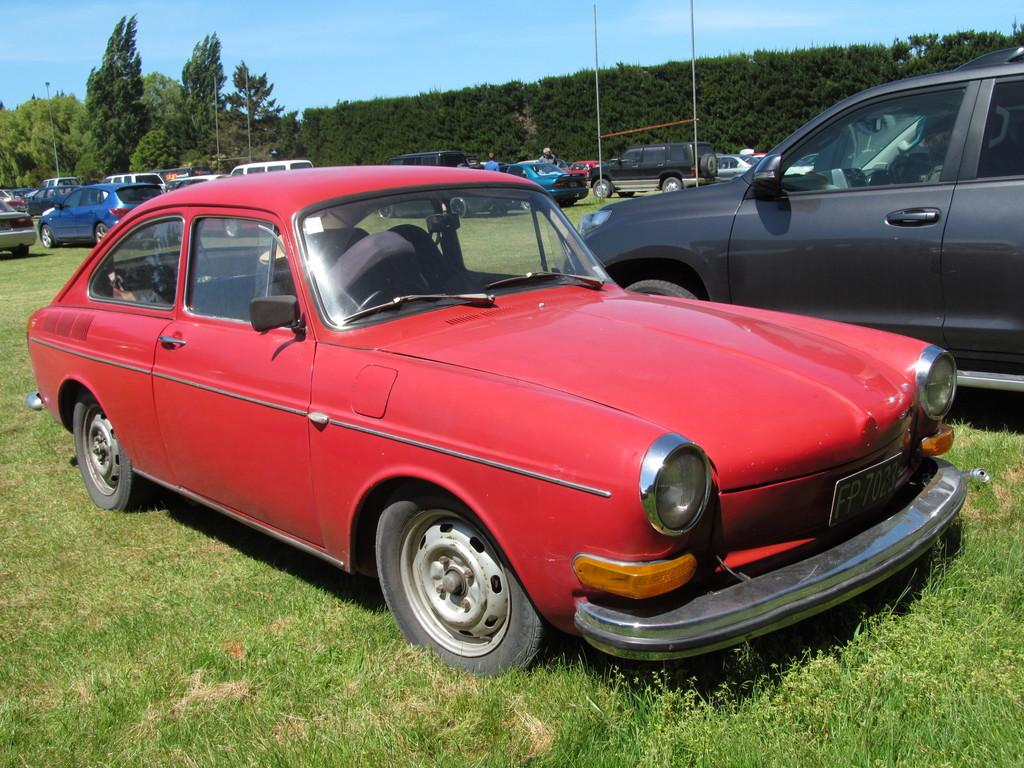What is the location of the vehicles in the image? The vehicles are parked on the grass in the image. What can be seen behind the vehicles? There are people visible behind the vehicles. What type of structures are present in the image? There are poles visible in the image. What is the natural setting visible in the image? There are trees in the background and the sky is visible in the image. What type of tank is being used for a volleyball game in the image? There is no tank or volleyball game present in the image. What is the wrist of the person holding the ball in the image? There is no person holding a ball or any wrist visible in the image. 